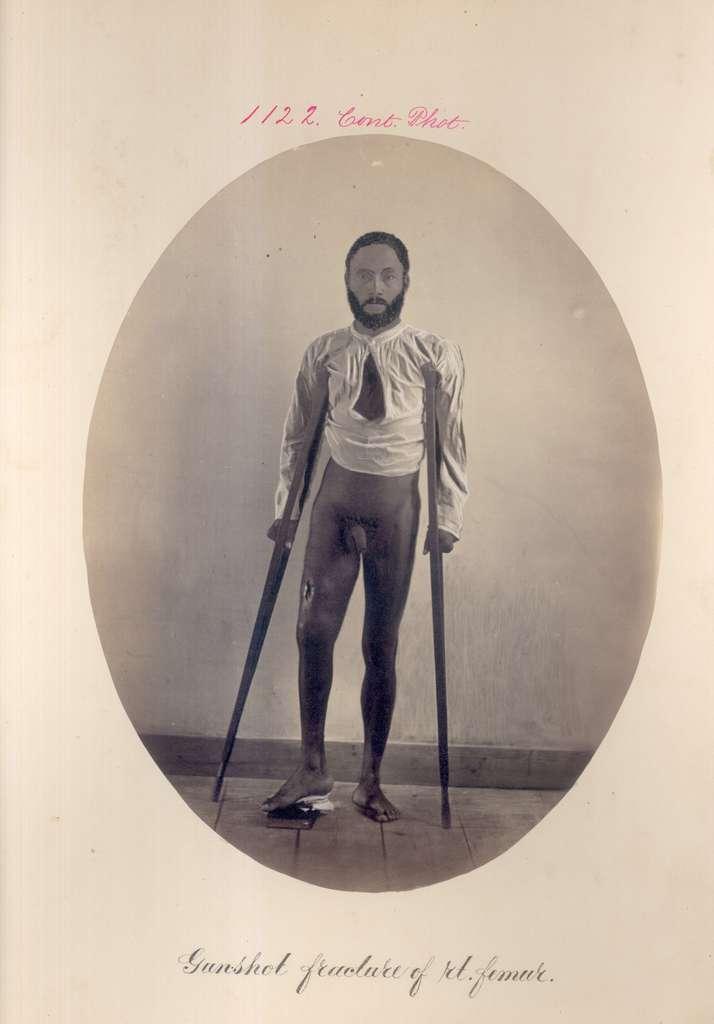Can you describe this image briefly? In this image we can see a paper with a picture of a person, also we can see text on it. 